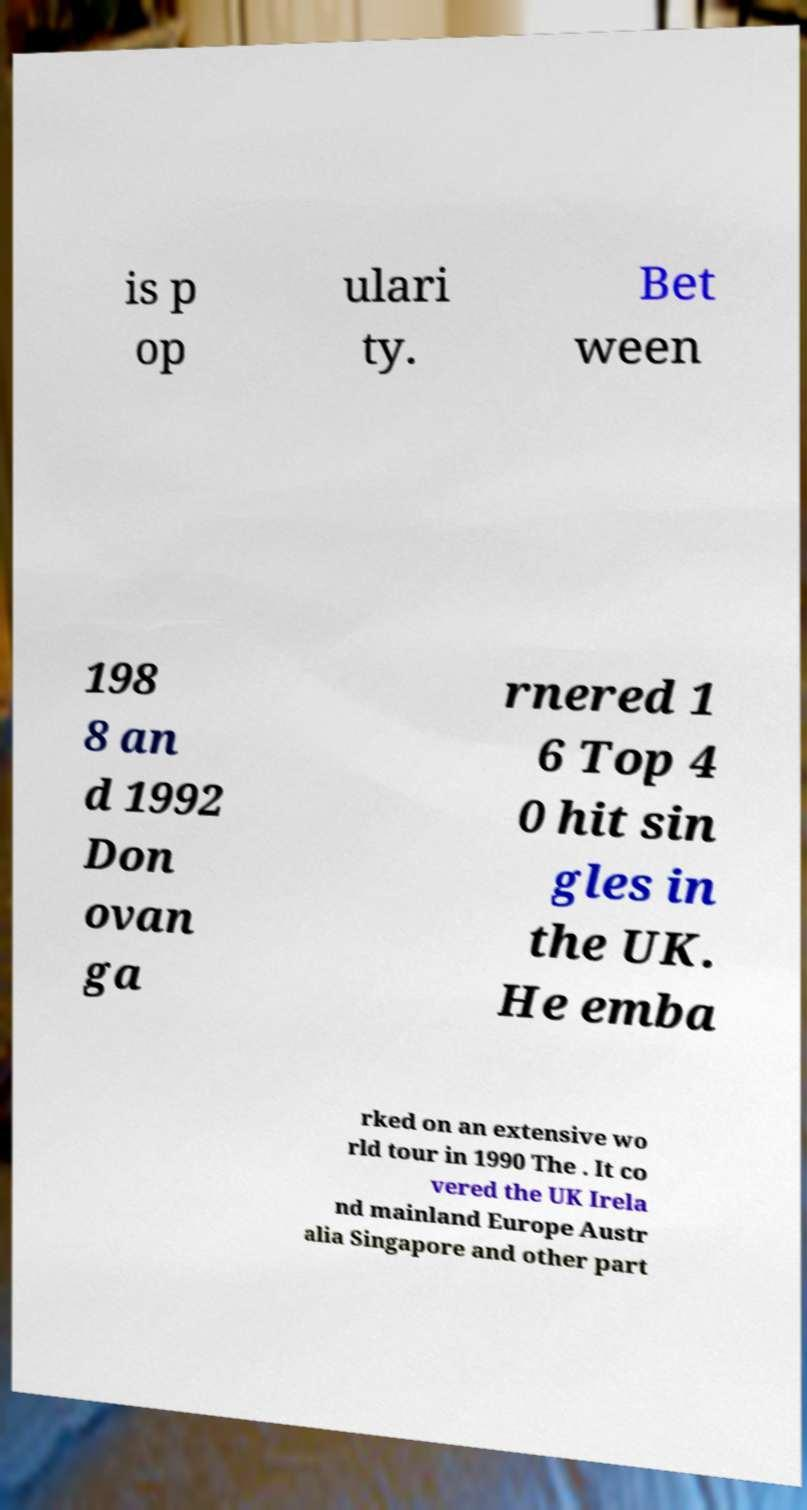What messages or text are displayed in this image? I need them in a readable, typed format. is p op ulari ty. Bet ween 198 8 an d 1992 Don ovan ga rnered 1 6 Top 4 0 hit sin gles in the UK. He emba rked on an extensive wo rld tour in 1990 The . It co vered the UK Irela nd mainland Europe Austr alia Singapore and other part 